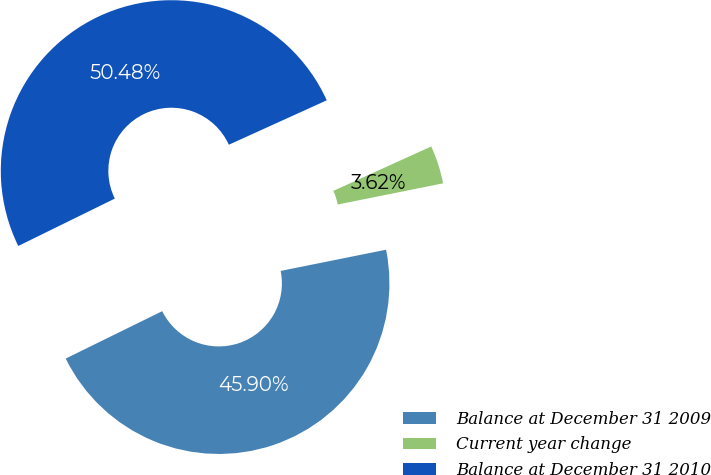Convert chart to OTSL. <chart><loc_0><loc_0><loc_500><loc_500><pie_chart><fcel>Balance at December 31 2009<fcel>Current year change<fcel>Balance at December 31 2010<nl><fcel>45.9%<fcel>3.62%<fcel>50.49%<nl></chart> 